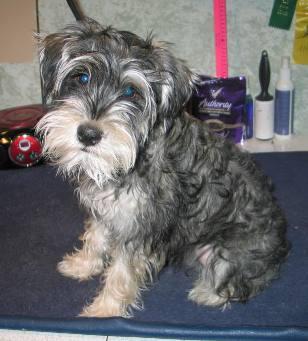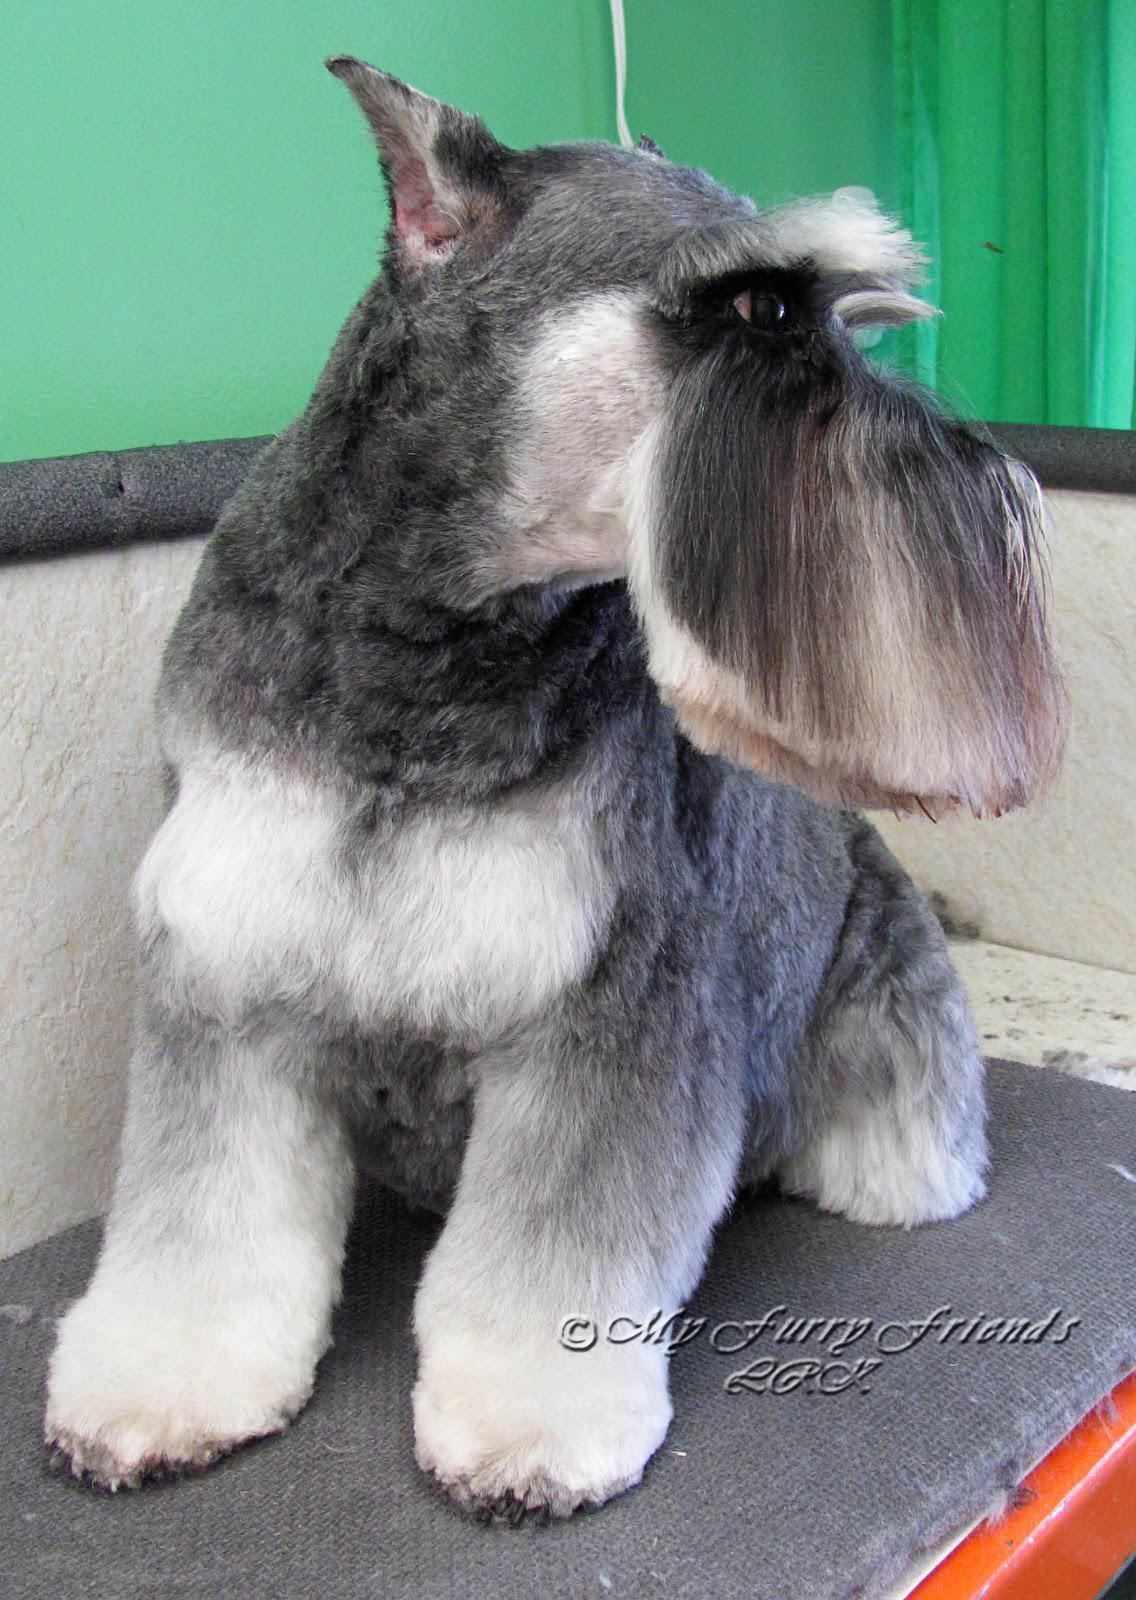The first image is the image on the left, the second image is the image on the right. Given the left and right images, does the statement "A dog poses in one of the images, on a table, in front of a green wall." hold true? Answer yes or no. Yes. The first image is the image on the left, the second image is the image on the right. For the images shown, is this caption "the right image has a dog on a gray floor mat and green walls" true? Answer yes or no. Yes. 